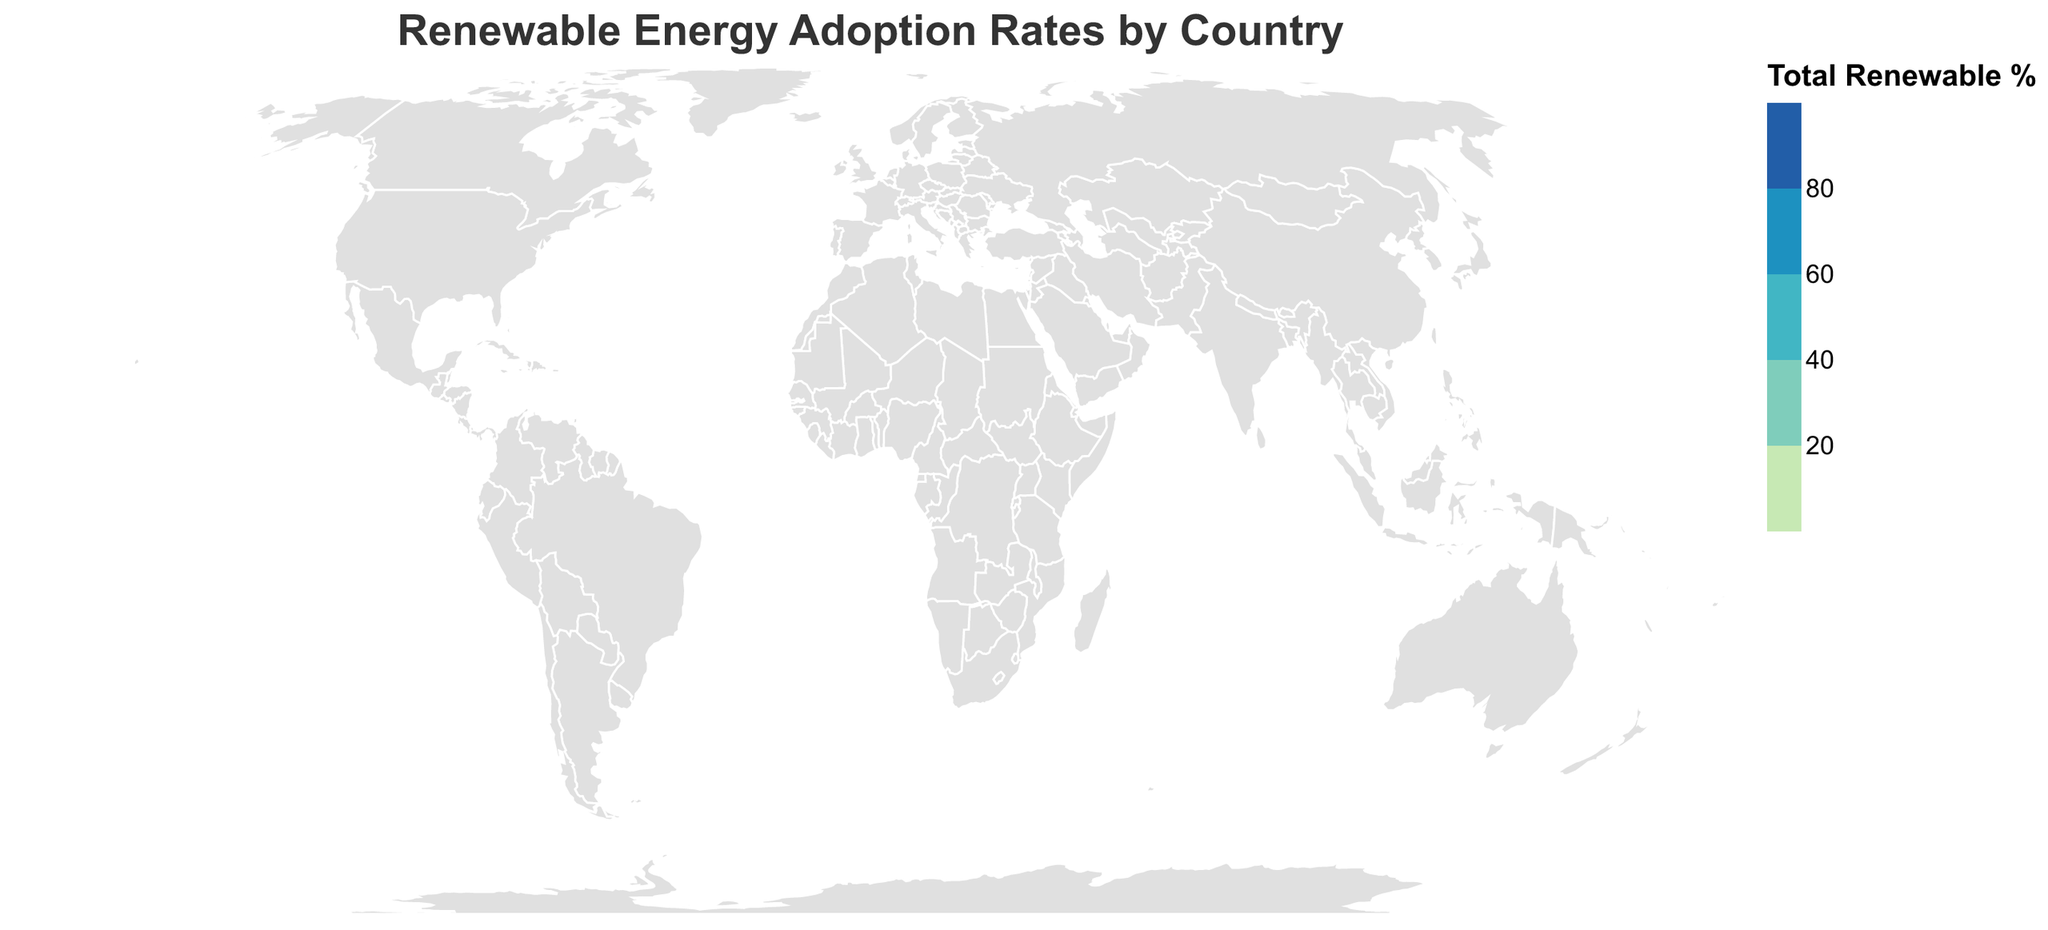What is the title of the figure? The title of the figure is displayed at the top and it reads "Renewable Energy Adoption Rates by Country".
Answer: Renewable Energy Adoption Rates by Country Which country has the highest contribution from wind energy? According to the tooltip information, Denmark has the highest wind energy contribution at 47.1%.
Answer: Denmark What are the total renewable energy adoption rates for China and India? We add the individual renewable energy contributions for each country. For China: 3.5 (Solar) + 5.2 (Wind) + 17.8 (Hydro) + 0.0 (Geothermal) + 3.1 (Biomass) = 29.6. For India: 4.1 (Solar) + 4.7 (Wind) + 9.2 (Hydro) + 0.0 (Geothermal) + 2.5 (Biomass) = 20.5.
Answer: China: 29.6, India: 20.5 Which country ranks third in terms of biomass energy adoption rate? According to the tooltip, we can see that Brazil ranks first in biomass at 8.7%, followed by Denmark at 12.4%, and then Sweden with 9.1%.
Answer: Sweden How many countries have renewable energy adoption rates above 60%? Check the total renewable percentage in the tooltip for each country. Brazil (82.0%) and Canada (66.9%) have above 60%. That makes 2 countries.
Answer: 2 Which country has the least contribution from hydro energy? According to the tooltip on the map, both Denmark and Netherlands have the lowest hydro energy contribution at 0.1%.
Answer: Denmark and Netherlands How does the total renewable energy adoption rate of the United States compare to that of Germany? Total renewable for the United States is 2.8 + 8.4 + 7.3 + 0.4 + 1.6 = 20.5. For Germany, it is 8.7 + 24.6 + 3.4 + 0.0 + 8.2 = 44.9. Germany has a higher total renewable energy adoption rate than the United States.
Answer: Germany has a higher total What is the color scale range used for total renewable percentage in the map? The color scale ranges from "#c7e9b4" for low total renewable percentages to "#225ea8" for high total percentages.
Answer: #c7e9b4 to #225ea8 